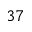<formula> <loc_0><loc_0><loc_500><loc_500>^ { 3 7 }</formula> 